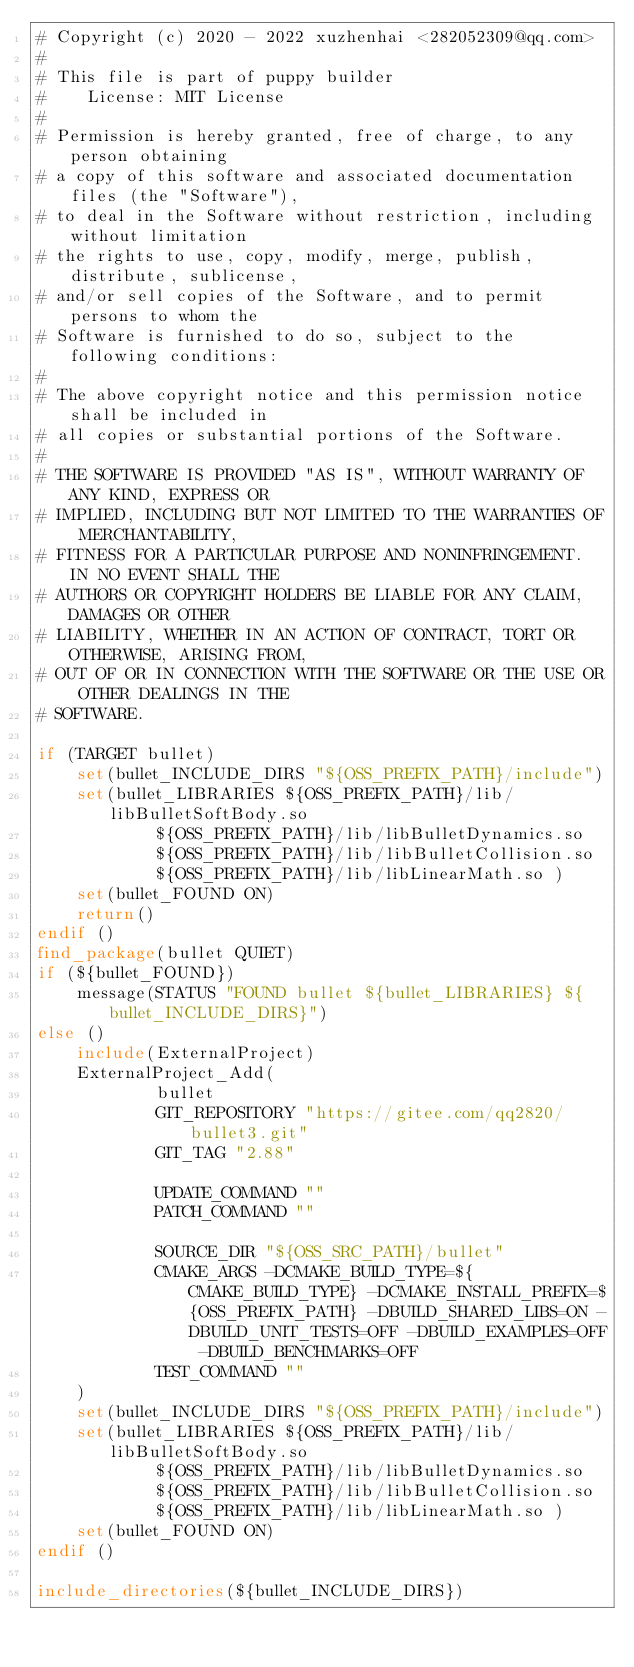<code> <loc_0><loc_0><loc_500><loc_500><_CMake_># Copyright (c) 2020 - 2022 xuzhenhai <282052309@qq.com>
#
# This file is part of puppy builder
#    License: MIT License
#
# Permission is hereby granted, free of charge, to any person obtaining
# a copy of this software and associated documentation files (the "Software"),
# to deal in the Software without restriction, including without limitation
# the rights to use, copy, modify, merge, publish, distribute, sublicense,
# and/or sell copies of the Software, and to permit persons to whom the
# Software is furnished to do so, subject to the following conditions:
#
# The above copyright notice and this permission notice shall be included in
# all copies or substantial portions of the Software.
#
# THE SOFTWARE IS PROVIDED "AS IS", WITHOUT WARRANTY OF ANY KIND, EXPRESS OR
# IMPLIED, INCLUDING BUT NOT LIMITED TO THE WARRANTIES OF MERCHANTABILITY,
# FITNESS FOR A PARTICULAR PURPOSE AND NONINFRINGEMENT. IN NO EVENT SHALL THE
# AUTHORS OR COPYRIGHT HOLDERS BE LIABLE FOR ANY CLAIM, DAMAGES OR OTHER
# LIABILITY, WHETHER IN AN ACTION OF CONTRACT, TORT OR OTHERWISE, ARISING FROM,
# OUT OF OR IN CONNECTION WITH THE SOFTWARE OR THE USE OR OTHER DEALINGS IN THE
# SOFTWARE.

if (TARGET bullet)
    set(bullet_INCLUDE_DIRS "${OSS_PREFIX_PATH}/include")
    set(bullet_LIBRARIES ${OSS_PREFIX_PATH}/lib/libBulletSoftBody.so
            ${OSS_PREFIX_PATH}/lib/libBulletDynamics.so
            ${OSS_PREFIX_PATH}/lib/libBulletCollision.so
            ${OSS_PREFIX_PATH}/lib/libLinearMath.so )
    set(bullet_FOUND ON)
    return()
endif ()
find_package(bullet QUIET)
if (${bullet_FOUND})
    message(STATUS "FOUND bullet ${bullet_LIBRARIES} ${bullet_INCLUDE_DIRS}")
else ()
    include(ExternalProject)
    ExternalProject_Add(
            bullet
            GIT_REPOSITORY "https://gitee.com/qq2820/bullet3.git"
            GIT_TAG "2.88"

            UPDATE_COMMAND ""
            PATCH_COMMAND ""

            SOURCE_DIR "${OSS_SRC_PATH}/bullet"
            CMAKE_ARGS -DCMAKE_BUILD_TYPE=${CMAKE_BUILD_TYPE} -DCMAKE_INSTALL_PREFIX=${OSS_PREFIX_PATH} -DBUILD_SHARED_LIBS=ON -DBUILD_UNIT_TESTS=OFF -DBUILD_EXAMPLES=OFF -DBUILD_BENCHMARKS=OFF
            TEST_COMMAND ""
    )
    set(bullet_INCLUDE_DIRS "${OSS_PREFIX_PATH}/include")
    set(bullet_LIBRARIES ${OSS_PREFIX_PATH}/lib/libBulletSoftBody.so
            ${OSS_PREFIX_PATH}/lib/libBulletDynamics.so
            ${OSS_PREFIX_PATH}/lib/libBulletCollision.so
            ${OSS_PREFIX_PATH}/lib/libLinearMath.so )
    set(bullet_FOUND ON)
endif ()

include_directories(${bullet_INCLUDE_DIRS})</code> 